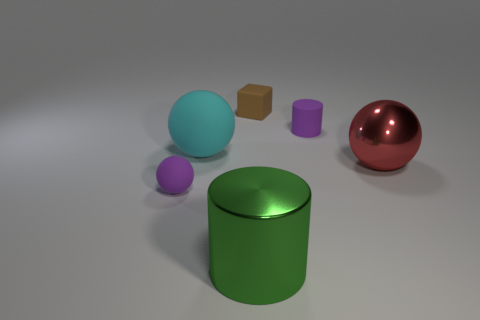Subtract all matte balls. How many balls are left? 1 Add 3 tiny brown matte balls. How many objects exist? 9 Subtract all cubes. How many objects are left? 5 Subtract all brown balls. Subtract all yellow cubes. How many balls are left? 3 Add 6 brown matte things. How many brown matte things exist? 7 Subtract 0 yellow cubes. How many objects are left? 6 Subtract all brown rubber things. Subtract all cylinders. How many objects are left? 3 Add 3 metallic things. How many metallic things are left? 5 